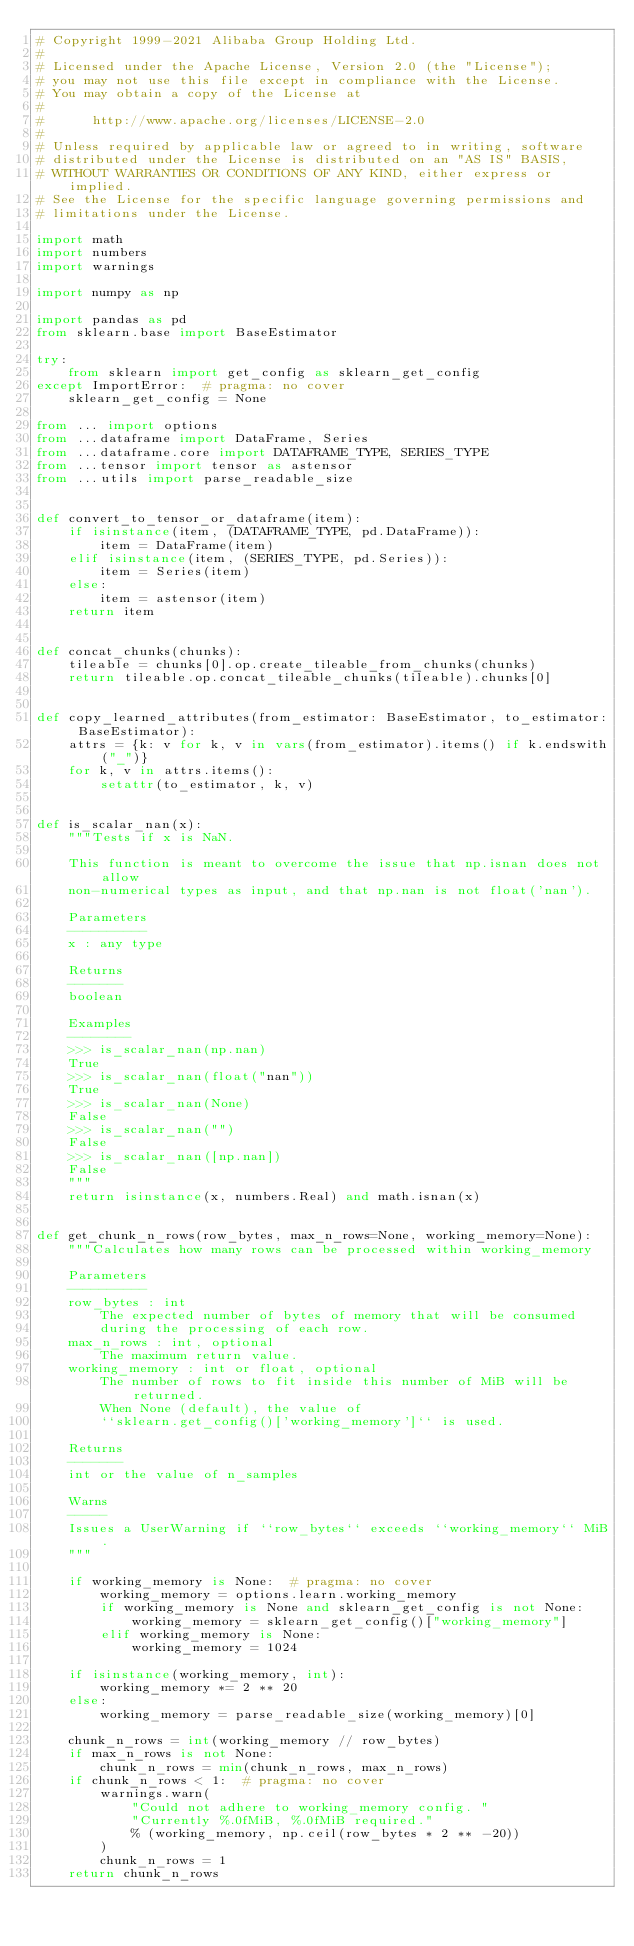<code> <loc_0><loc_0><loc_500><loc_500><_Python_># Copyright 1999-2021 Alibaba Group Holding Ltd.
#
# Licensed under the Apache License, Version 2.0 (the "License");
# you may not use this file except in compliance with the License.
# You may obtain a copy of the License at
#
#      http://www.apache.org/licenses/LICENSE-2.0
#
# Unless required by applicable law or agreed to in writing, software
# distributed under the License is distributed on an "AS IS" BASIS,
# WITHOUT WARRANTIES OR CONDITIONS OF ANY KIND, either express or implied.
# See the License for the specific language governing permissions and
# limitations under the License.

import math
import numbers
import warnings

import numpy as np

import pandas as pd
from sklearn.base import BaseEstimator

try:
    from sklearn import get_config as sklearn_get_config
except ImportError:  # pragma: no cover
    sklearn_get_config = None

from ... import options
from ...dataframe import DataFrame, Series
from ...dataframe.core import DATAFRAME_TYPE, SERIES_TYPE
from ...tensor import tensor as astensor
from ...utils import parse_readable_size


def convert_to_tensor_or_dataframe(item):
    if isinstance(item, (DATAFRAME_TYPE, pd.DataFrame)):
        item = DataFrame(item)
    elif isinstance(item, (SERIES_TYPE, pd.Series)):
        item = Series(item)
    else:
        item = astensor(item)
    return item


def concat_chunks(chunks):
    tileable = chunks[0].op.create_tileable_from_chunks(chunks)
    return tileable.op.concat_tileable_chunks(tileable).chunks[0]


def copy_learned_attributes(from_estimator: BaseEstimator, to_estimator: BaseEstimator):
    attrs = {k: v for k, v in vars(from_estimator).items() if k.endswith("_")}
    for k, v in attrs.items():
        setattr(to_estimator, k, v)


def is_scalar_nan(x):
    """Tests if x is NaN.

    This function is meant to overcome the issue that np.isnan does not allow
    non-numerical types as input, and that np.nan is not float('nan').

    Parameters
    ----------
    x : any type

    Returns
    -------
    boolean

    Examples
    --------
    >>> is_scalar_nan(np.nan)
    True
    >>> is_scalar_nan(float("nan"))
    True
    >>> is_scalar_nan(None)
    False
    >>> is_scalar_nan("")
    False
    >>> is_scalar_nan([np.nan])
    False
    """
    return isinstance(x, numbers.Real) and math.isnan(x)


def get_chunk_n_rows(row_bytes, max_n_rows=None, working_memory=None):
    """Calculates how many rows can be processed within working_memory

    Parameters
    ----------
    row_bytes : int
        The expected number of bytes of memory that will be consumed
        during the processing of each row.
    max_n_rows : int, optional
        The maximum return value.
    working_memory : int or float, optional
        The number of rows to fit inside this number of MiB will be returned.
        When None (default), the value of
        ``sklearn.get_config()['working_memory']`` is used.

    Returns
    -------
    int or the value of n_samples

    Warns
    -----
    Issues a UserWarning if ``row_bytes`` exceeds ``working_memory`` MiB.
    """

    if working_memory is None:  # pragma: no cover
        working_memory = options.learn.working_memory
        if working_memory is None and sklearn_get_config is not None:
            working_memory = sklearn_get_config()["working_memory"]
        elif working_memory is None:
            working_memory = 1024

    if isinstance(working_memory, int):
        working_memory *= 2 ** 20
    else:
        working_memory = parse_readable_size(working_memory)[0]

    chunk_n_rows = int(working_memory // row_bytes)
    if max_n_rows is not None:
        chunk_n_rows = min(chunk_n_rows, max_n_rows)
    if chunk_n_rows < 1:  # pragma: no cover
        warnings.warn(
            "Could not adhere to working_memory config. "
            "Currently %.0fMiB, %.0fMiB required."
            % (working_memory, np.ceil(row_bytes * 2 ** -20))
        )
        chunk_n_rows = 1
    return chunk_n_rows
</code> 